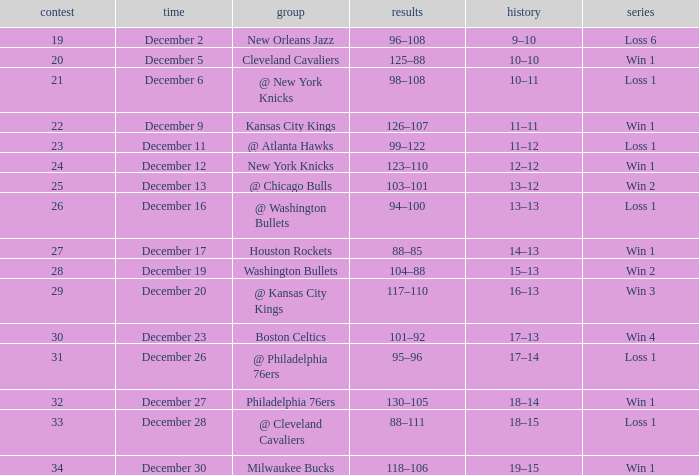Would you be able to parse every entry in this table? {'header': ['contest', 'time', 'group', 'results', 'history', 'series'], 'rows': [['19', 'December 2', 'New Orleans Jazz', '96–108', '9–10', 'Loss 6'], ['20', 'December 5', 'Cleveland Cavaliers', '125–88', '10–10', 'Win 1'], ['21', 'December 6', '@ New York Knicks', '98–108', '10–11', 'Loss 1'], ['22', 'December 9', 'Kansas City Kings', '126–107', '11–11', 'Win 1'], ['23', 'December 11', '@ Atlanta Hawks', '99–122', '11–12', 'Loss 1'], ['24', 'December 12', 'New York Knicks', '123–110', '12–12', 'Win 1'], ['25', 'December 13', '@ Chicago Bulls', '103–101', '13–12', 'Win 2'], ['26', 'December 16', '@ Washington Bullets', '94–100', '13–13', 'Loss 1'], ['27', 'December 17', 'Houston Rockets', '88–85', '14–13', 'Win 1'], ['28', 'December 19', 'Washington Bullets', '104–88', '15–13', 'Win 2'], ['29', 'December 20', '@ Kansas City Kings', '117–110', '16–13', 'Win 3'], ['30', 'December 23', 'Boston Celtics', '101–92', '17–13', 'Win 4'], ['31', 'December 26', '@ Philadelphia 76ers', '95–96', '17–14', 'Loss 1'], ['32', 'December 27', 'Philadelphia 76ers', '130–105', '18–14', 'Win 1'], ['33', 'December 28', '@ Cleveland Cavaliers', '88–111', '18–15', 'Loss 1'], ['34', 'December 30', 'Milwaukee Bucks', '118–106', '19–15', 'Win 1']]} What is the Score of the Game with a Record of 13–12? 103–101. 